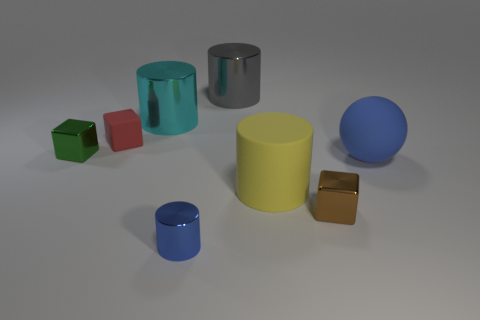Subtract all tiny red rubber blocks. How many blocks are left? 2 Add 1 yellow objects. How many objects exist? 9 Subtract all brown cubes. How many cubes are left? 2 Subtract 1 spheres. How many spheres are left? 0 Subtract all spheres. How many objects are left? 7 Subtract all brown objects. Subtract all tiny brown metal blocks. How many objects are left? 6 Add 3 small blue objects. How many small blue objects are left? 4 Add 2 rubber objects. How many rubber objects exist? 5 Subtract 0 brown cylinders. How many objects are left? 8 Subtract all brown cylinders. Subtract all cyan balls. How many cylinders are left? 4 